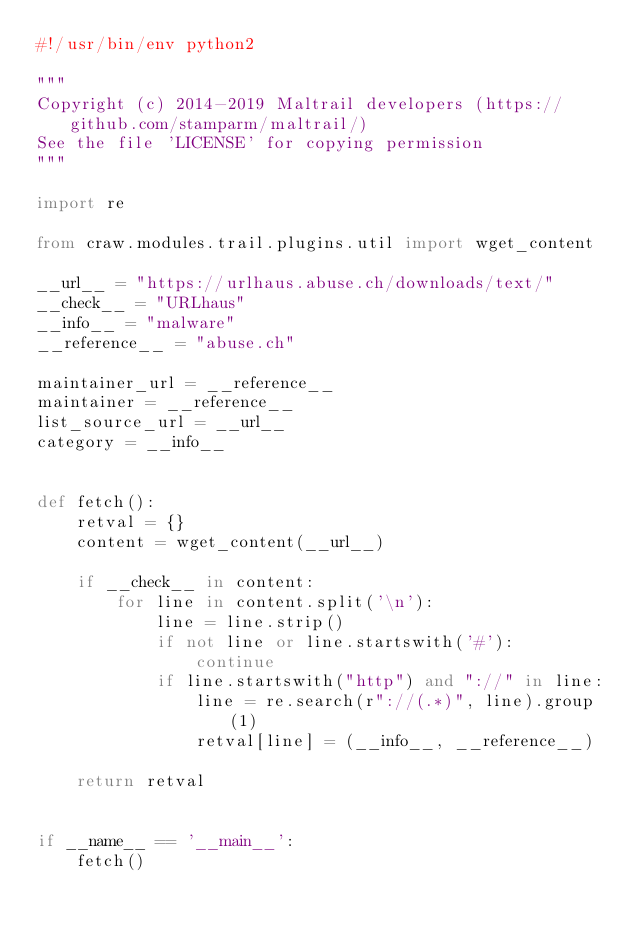<code> <loc_0><loc_0><loc_500><loc_500><_Python_>#!/usr/bin/env python2

"""
Copyright (c) 2014-2019 Maltrail developers (https://github.com/stamparm/maltrail/)
See the file 'LICENSE' for copying permission
"""

import re

from craw.modules.trail.plugins.util import wget_content

__url__ = "https://urlhaus.abuse.ch/downloads/text/"
__check__ = "URLhaus"
__info__ = "malware"
__reference__ = "abuse.ch"

maintainer_url = __reference__
maintainer = __reference__
list_source_url = __url__
category = __info__


def fetch():
    retval = {}
    content = wget_content(__url__)

    if __check__ in content:
        for line in content.split('\n'):
            line = line.strip()
            if not line or line.startswith('#'):
                continue
            if line.startswith("http") and "://" in line:
                line = re.search(r"://(.*)", line).group(1)
                retval[line] = (__info__, __reference__)

    return retval


if __name__ == '__main__':
    fetch()
</code> 